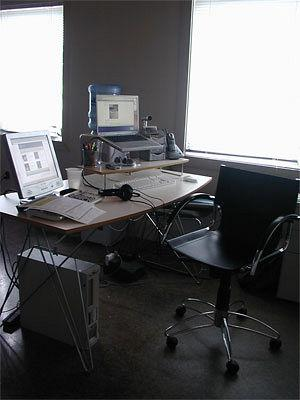This computer desk is in what type of building?

Choices:
A) dormitory
B) home
C) commercial office
D) apartment commercial office 